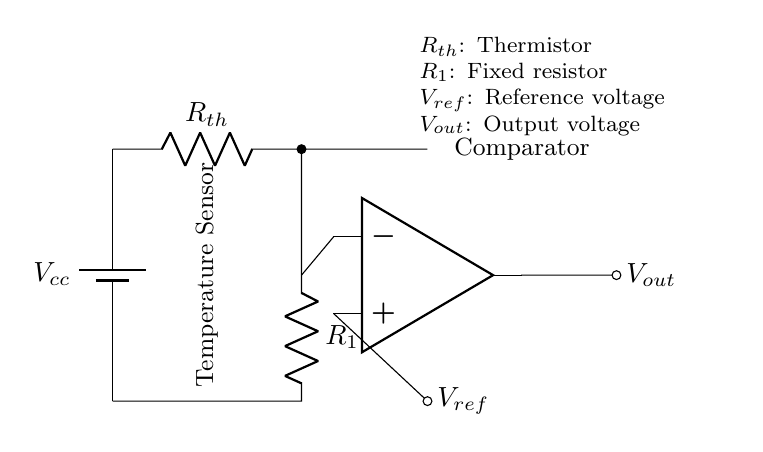What type of sensor is used in this circuit? The circuit incorporates a thermistor, which is a temperature-sensitive resistor. This can be identified by the label Rth in the diagram.
Answer: Thermistor What is the reference voltage denoted as? The reference voltage is indicated as Vref, which is shown in the output section of the circuit. This is crucial for the op-amp's comparison function.
Answer: V ref How many resistors are present in the circuit? There are two resistors: the thermistor Rth and the fixed resistor R1. Both are visible in the diagram as distinct elements.
Answer: Two What is the function of the op-amp in this circuit? The op-amp serves as a comparator, which compares the voltage at the inverting terminal with the reference voltage at the non-inverting terminal to determine the output voltage.
Answer: Comparator What is the output voltage denoted as? The output voltage is labeled Vout in the diagram, and it represents the voltage that results from the op-amp's comparison process.
Answer: V out What is the purpose of the fixed resistor R1? The fixed resistor R1 creates a voltage divider with the thermistor, allowing the circuit to measure temperature effectively by changing the voltage based on the temperature readings.
Answer: Voltage divider 